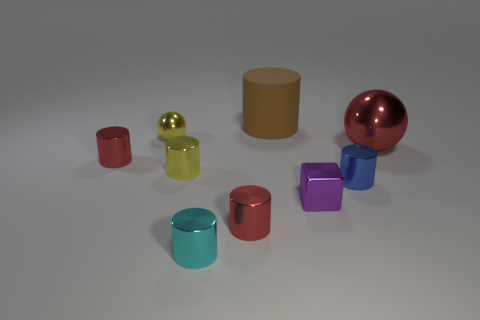Do the cyan metallic object and the red shiny cylinder that is to the right of the tiny shiny ball have the same size?
Ensure brevity in your answer.  Yes. What is the color of the shiny sphere that is on the left side of the ball that is in front of the small yellow ball?
Provide a short and direct response. Yellow. What number of objects are either small metal things that are on the right side of the small yellow metal ball or tiny metallic things in front of the purple object?
Provide a succinct answer. 5. Is the size of the brown rubber cylinder the same as the purple block?
Give a very brief answer. No. Do the yellow object that is right of the yellow sphere and the large thing on the right side of the tiny purple cube have the same shape?
Offer a very short reply. No. What is the size of the cube?
Your response must be concise. Small. There is a cylinder that is behind the tiny shiny thing behind the metal ball that is on the right side of the big brown thing; what is its material?
Your answer should be compact. Rubber. What number of other objects are the same color as the metallic block?
Offer a terse response. 0. What number of blue things are small metal cylinders or balls?
Keep it short and to the point. 1. There is a ball that is right of the big matte cylinder; what material is it?
Offer a very short reply. Metal. 